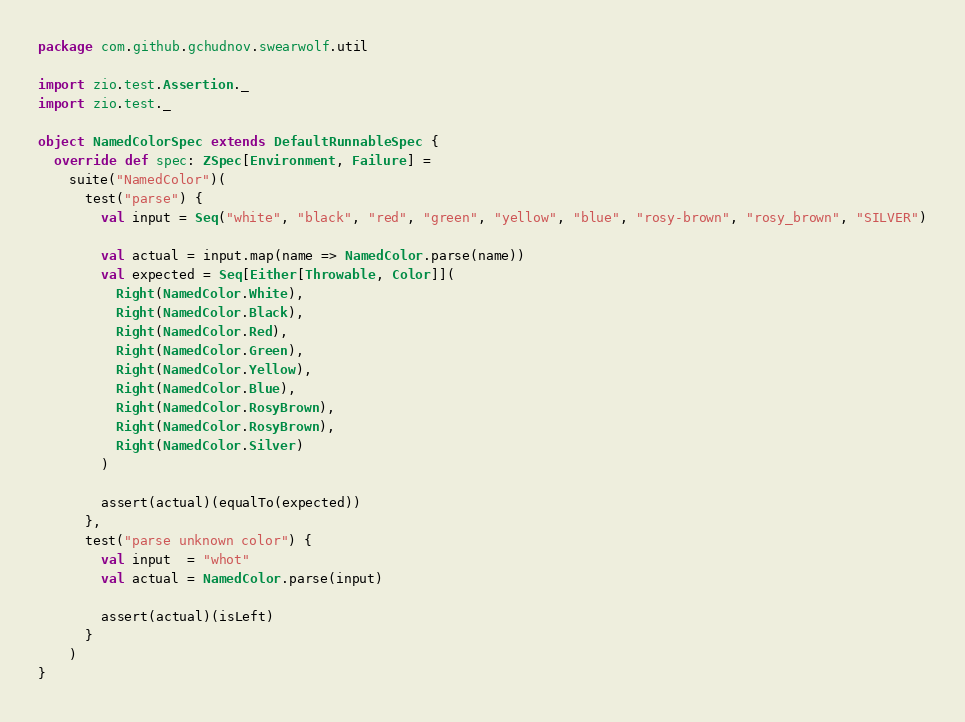Convert code to text. <code><loc_0><loc_0><loc_500><loc_500><_Scala_>package com.github.gchudnov.swearwolf.util

import zio.test.Assertion._
import zio.test._

object NamedColorSpec extends DefaultRunnableSpec {
  override def spec: ZSpec[Environment, Failure] =
    suite("NamedColor")(
      test("parse") {
        val input = Seq("white", "black", "red", "green", "yellow", "blue", "rosy-brown", "rosy_brown", "SILVER")

        val actual = input.map(name => NamedColor.parse(name))
        val expected = Seq[Either[Throwable, Color]](
          Right(NamedColor.White),
          Right(NamedColor.Black),
          Right(NamedColor.Red),
          Right(NamedColor.Green),
          Right(NamedColor.Yellow),
          Right(NamedColor.Blue),
          Right(NamedColor.RosyBrown),
          Right(NamedColor.RosyBrown),
          Right(NamedColor.Silver)
        )

        assert(actual)(equalTo(expected))
      },
      test("parse unknown color") {
        val input  = "whot"
        val actual = NamedColor.parse(input)

        assert(actual)(isLeft)
      }
    )
}
</code> 